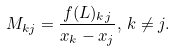<formula> <loc_0><loc_0><loc_500><loc_500>M _ { k j } = \frac { f ( L ) _ { k j } } { x _ { k } - x _ { j } } , \, k \neq j .</formula> 